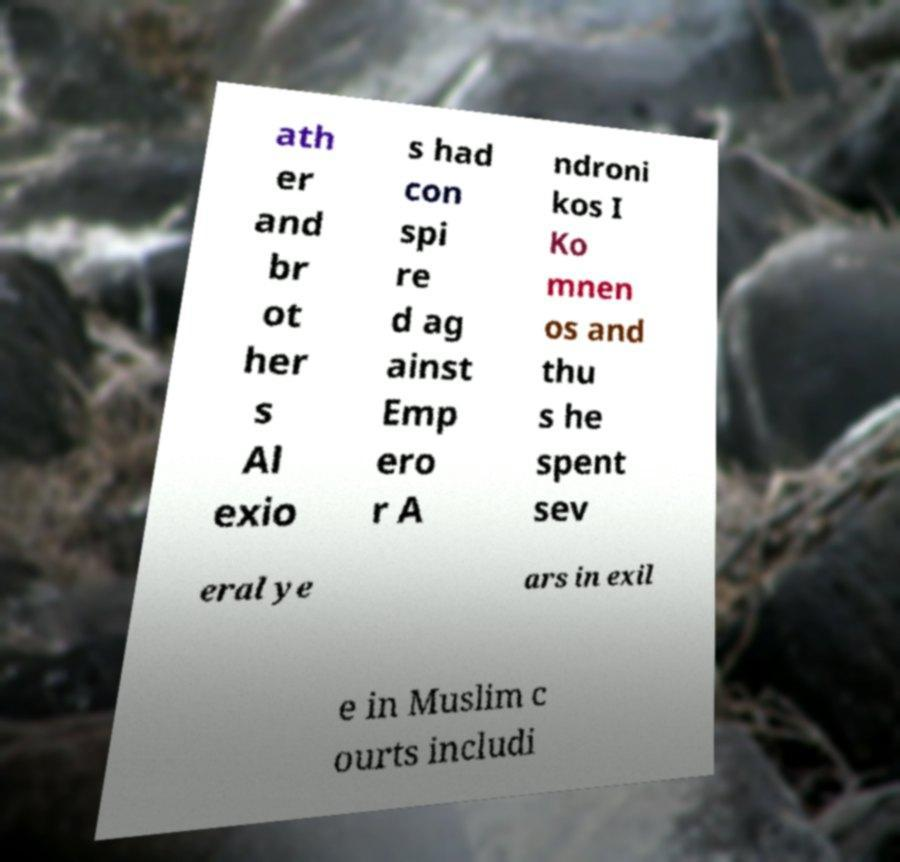Please read and relay the text visible in this image. What does it say? ath er and br ot her s Al exio s had con spi re d ag ainst Emp ero r A ndroni kos I Ko mnen os and thu s he spent sev eral ye ars in exil e in Muslim c ourts includi 